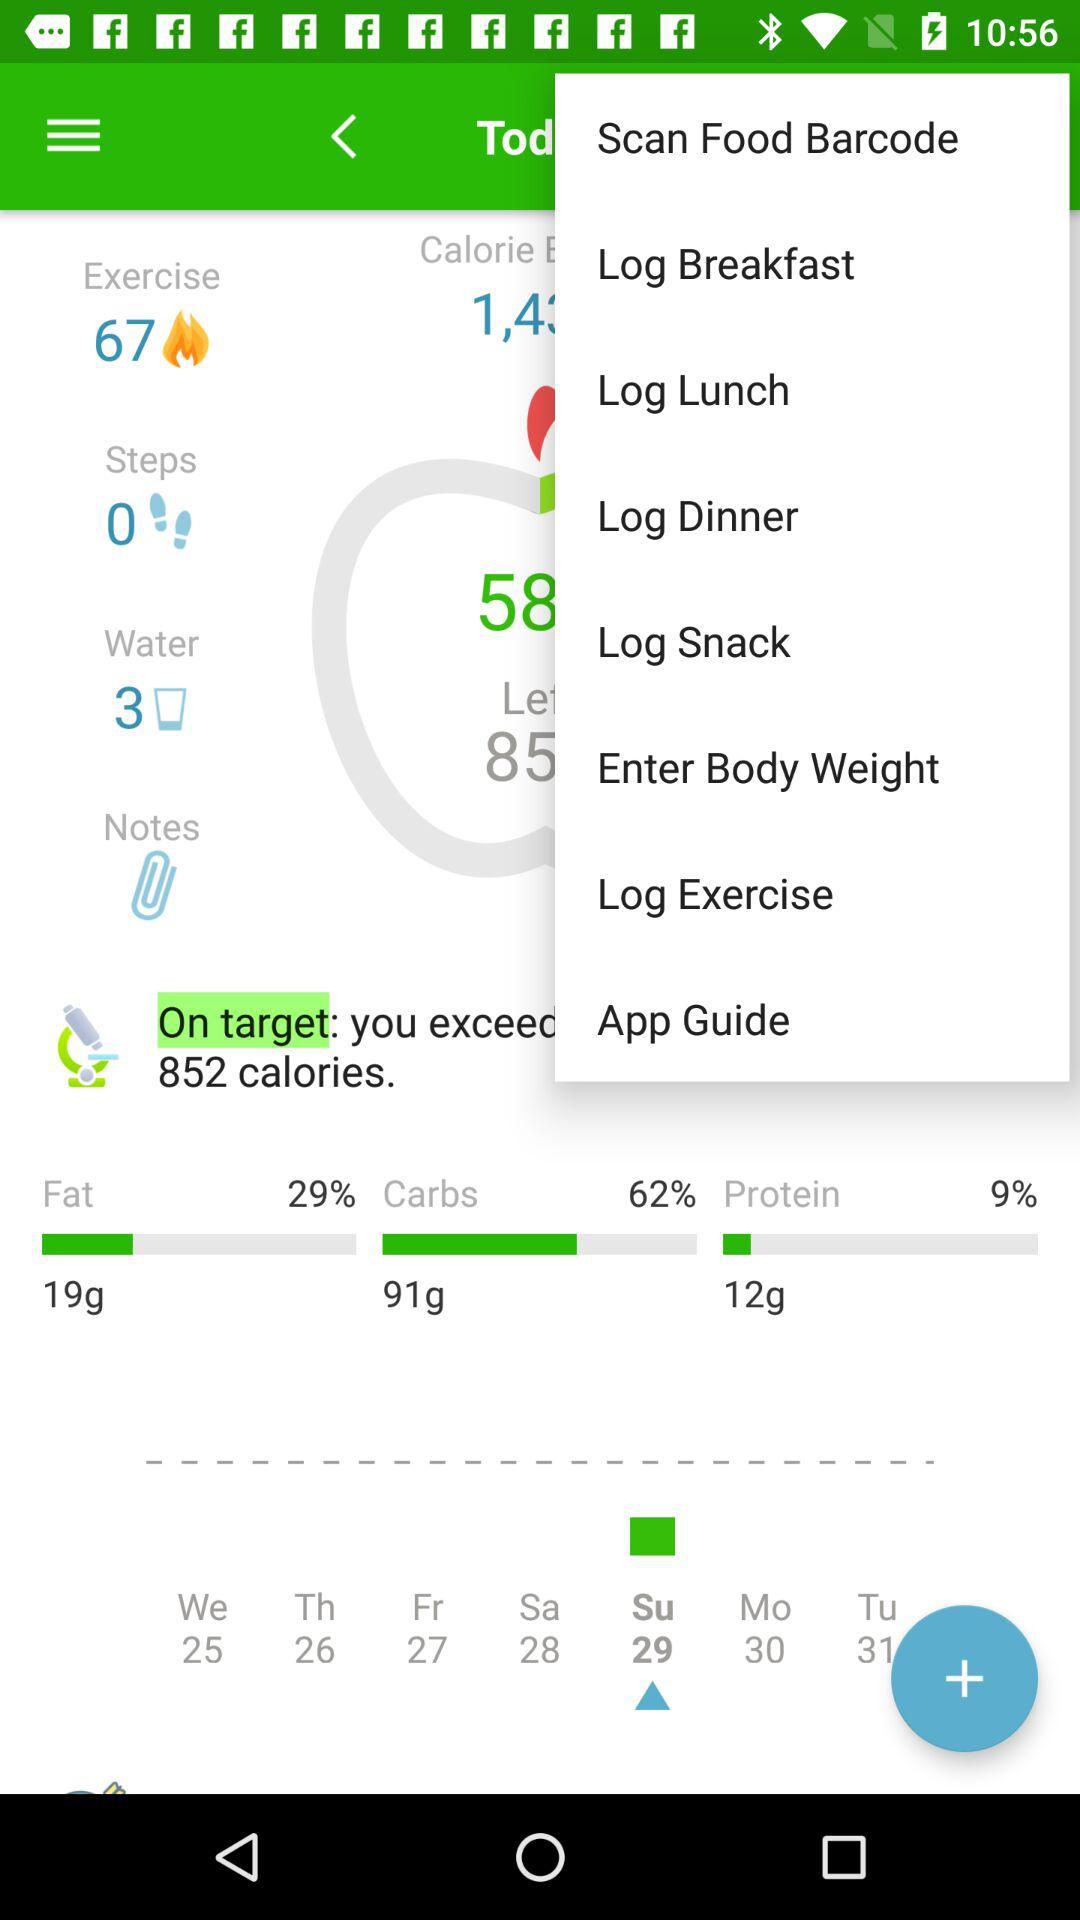How many steps are taken? There are 0 steps taken. 